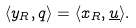Convert formula to latex. <formula><loc_0><loc_0><loc_500><loc_500>\langle y _ { R } , q \rangle = \langle x _ { R } , \underline { u } \rangle .</formula> 